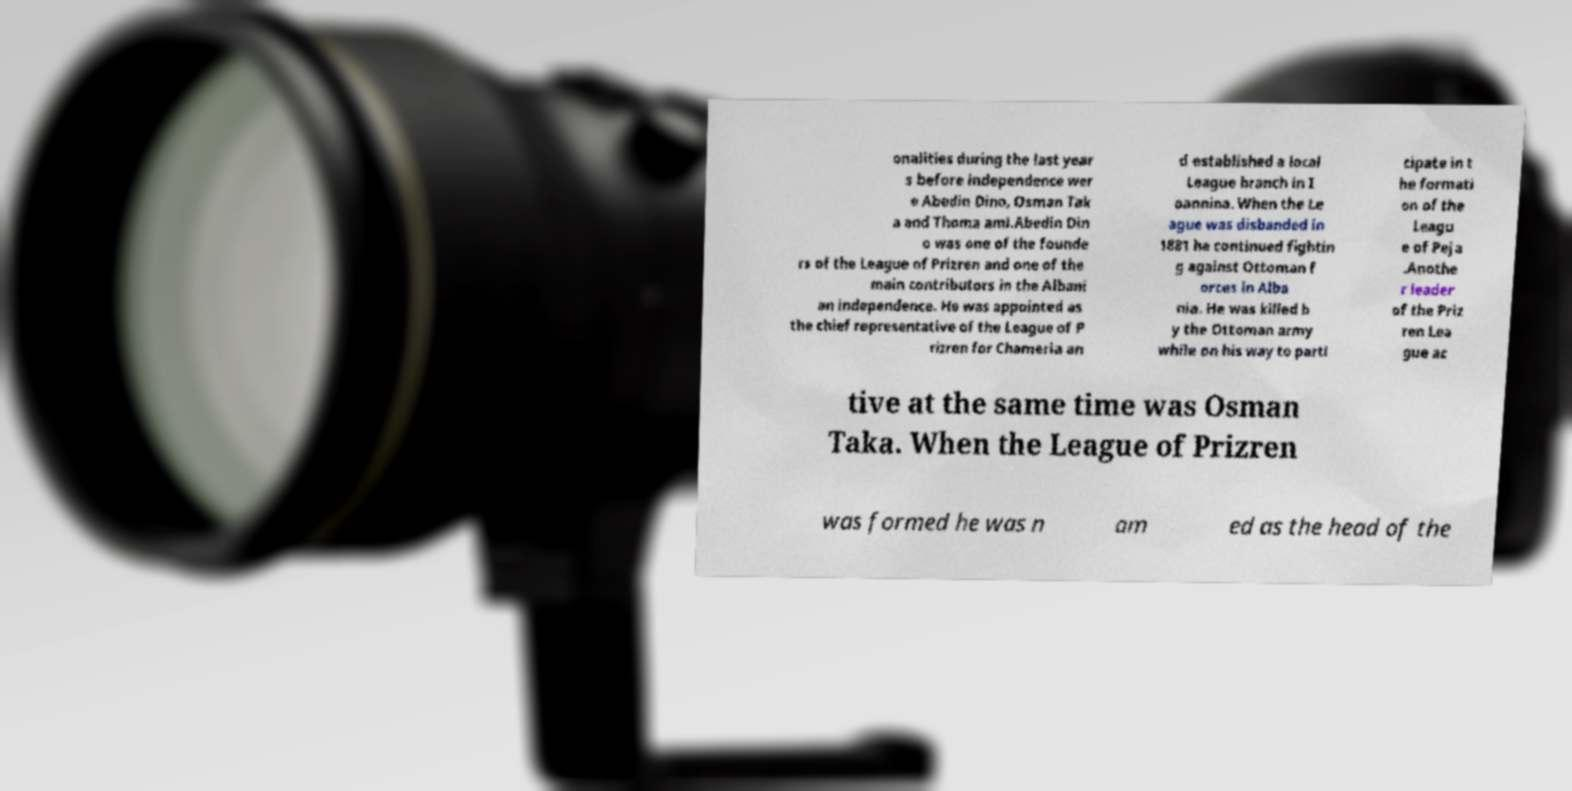Please identify and transcribe the text found in this image. onalities during the last year s before independence wer e Abedin Dino, Osman Tak a and Thoma ami.Abedin Din o was one of the founde rs of the League of Prizren and one of the main contributors in the Albani an independence. He was appointed as the chief representative of the League of P rizren for Chameria an d established a local League branch in I oannina. When the Le ague was disbanded in 1881 he continued fightin g against Ottoman f orces in Alba nia. He was killed b y the Ottoman army while on his way to parti cipate in t he formati on of the Leagu e of Peja .Anothe r leader of the Priz ren Lea gue ac tive at the same time was Osman Taka. When the League of Prizren was formed he was n am ed as the head of the 